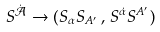<formula> <loc_0><loc_0><loc_500><loc_500>S ^ { \dot { \mathcal { A } } } \to ( S _ { \alpha } S _ { A ^ { \prime } } \, , \, S ^ { \dot { \alpha } } S ^ { A ^ { \prime } } )</formula> 